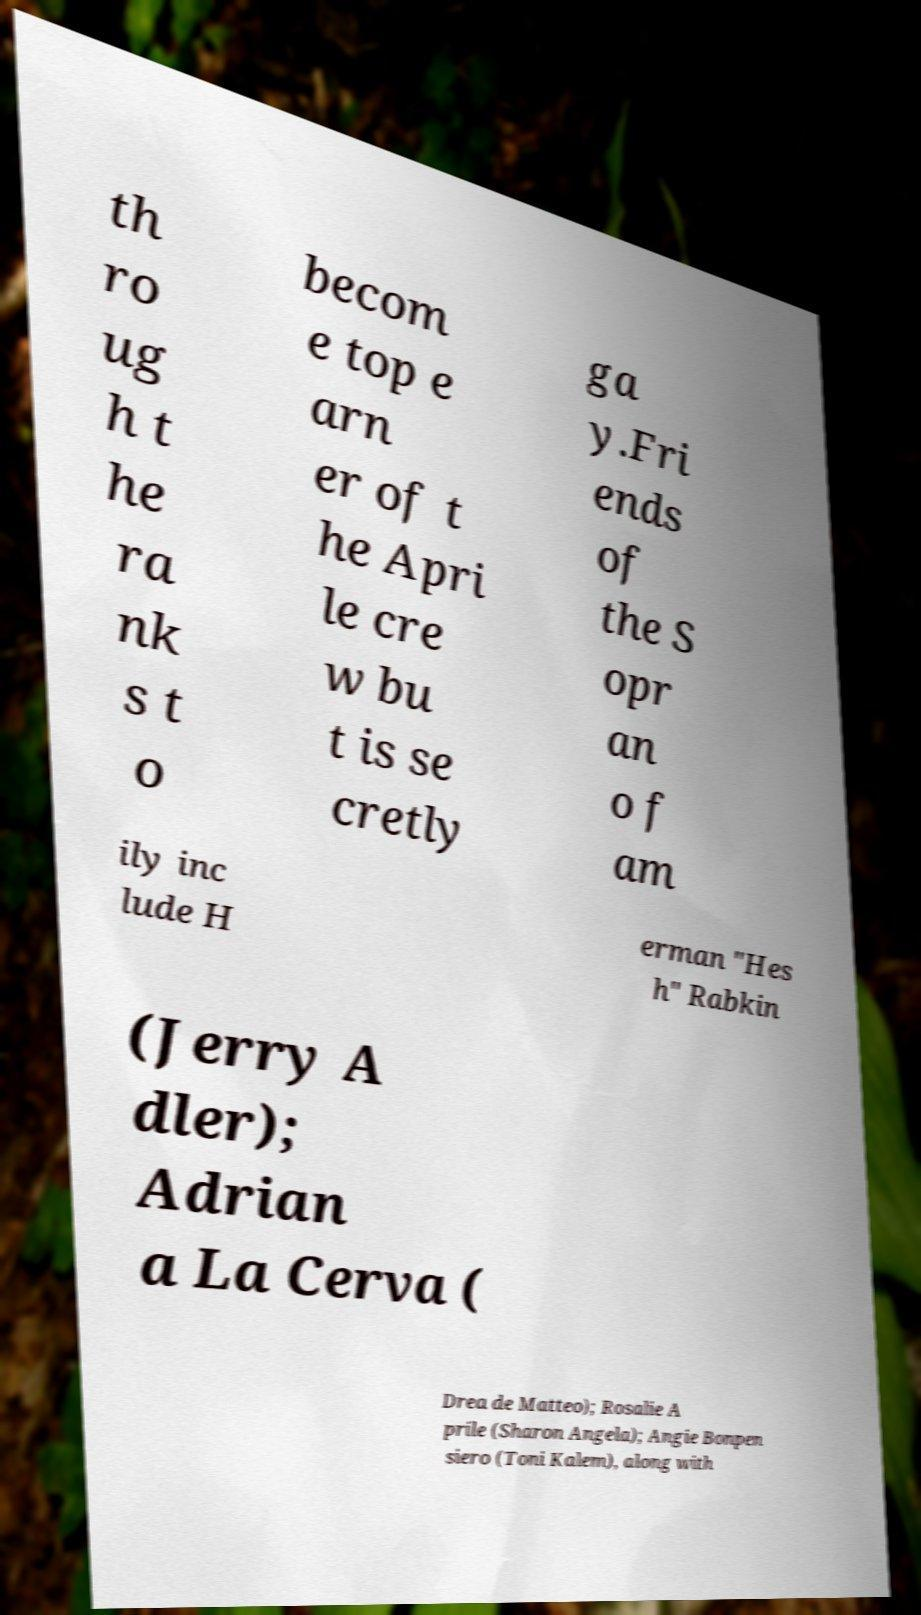Can you accurately transcribe the text from the provided image for me? th ro ug h t he ra nk s t o becom e top e arn er of t he Apri le cre w bu t is se cretly ga y.Fri ends of the S opr an o f am ily inc lude H erman "Hes h" Rabkin (Jerry A dler); Adrian a La Cerva ( Drea de Matteo); Rosalie A prile (Sharon Angela); Angie Bonpen siero (Toni Kalem), along with 